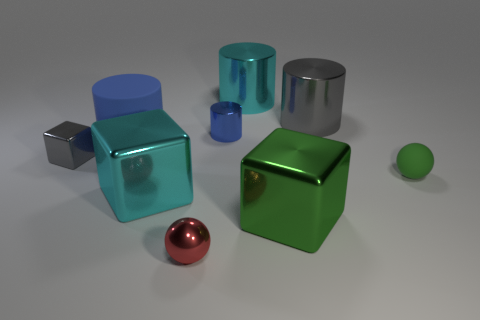Subtract all large blocks. How many blocks are left? 1 Add 1 small metal things. How many objects exist? 10 Subtract all green cubes. How many blue cylinders are left? 2 Subtract all red balls. How many balls are left? 1 Subtract 1 balls. How many balls are left? 1 Subtract all cylinders. How many objects are left? 5 Subtract all yellow cylinders. Subtract all red cubes. How many cylinders are left? 4 Subtract all large blue rubber things. Subtract all small gray cubes. How many objects are left? 7 Add 1 large blue rubber objects. How many large blue rubber objects are left? 2 Add 2 tiny metal cubes. How many tiny metal cubes exist? 3 